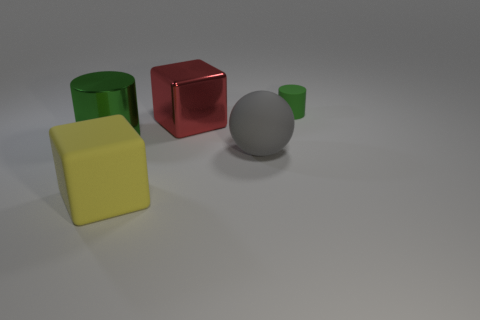How many things are either cubes or green metallic cylinders?
Ensure brevity in your answer.  3. There is a big shiny object right of the big green metallic thing; is its shape the same as the green thing that is on the right side of the gray object?
Give a very brief answer. No. There is a big matte object right of the red metallic block; what is its shape?
Your answer should be compact. Sphere. Is the number of rubber cubes that are behind the large cylinder the same as the number of big red shiny blocks in front of the matte sphere?
Provide a succinct answer. Yes. What number of objects are cyan rubber balls or green things that are behind the green shiny object?
Offer a terse response. 1. There is a thing that is right of the red metallic block and behind the large green thing; what is its shape?
Provide a succinct answer. Cylinder. There is a green object in front of the cylinder behind the large metal cube; what is it made of?
Ensure brevity in your answer.  Metal. Is the material of the green cylinder in front of the green rubber cylinder the same as the gray sphere?
Your response must be concise. No. What size is the shiny object on the right side of the large yellow matte thing?
Keep it short and to the point. Large. There is a large shiny object right of the large yellow rubber object; are there any small green cylinders that are in front of it?
Offer a very short reply. No. 